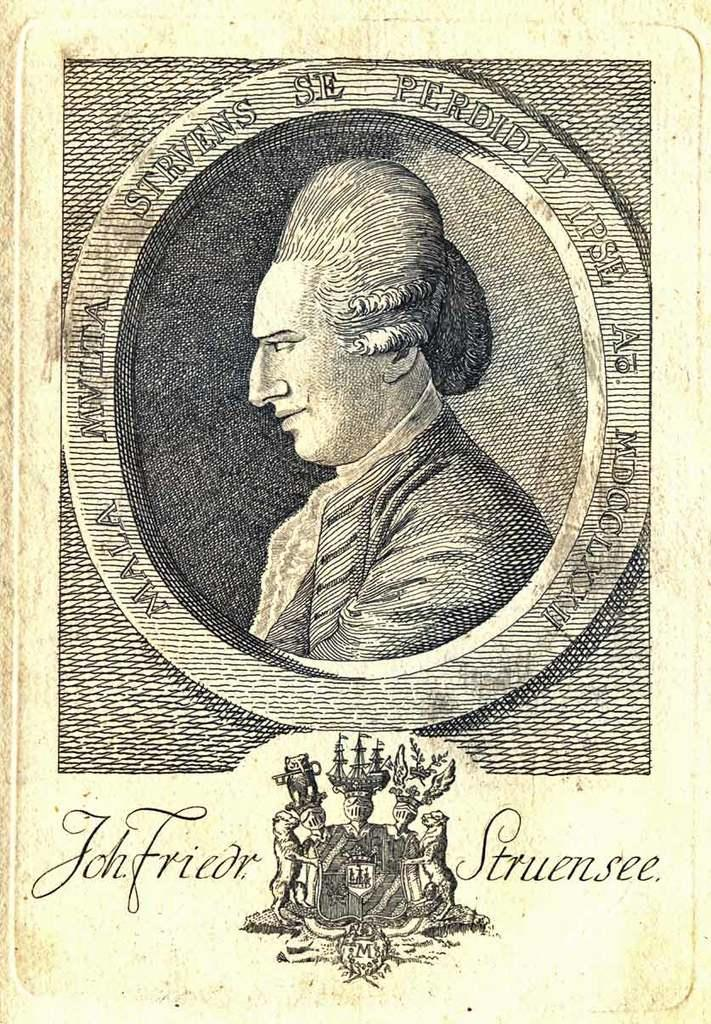What can be seen hanging on the wall in the picture? There is a poster in the picture. Who is present in the picture? There is a man in the picture. What else is visible in the picture besides the man and the poster? There is text in the picture. Can you describe the logo at the bottom of the picture? There appears to be a logo at the bottom of the picture. What type of pickle is being advertised in the picture? There is no pickle present in the picture; it features a poster, a man, text, and a logo. How does the nation contribute to the expansion of the product in the picture? There is no nation or product expansion mentioned in the picture; it only contains a poster, a man, text, and a logo. 